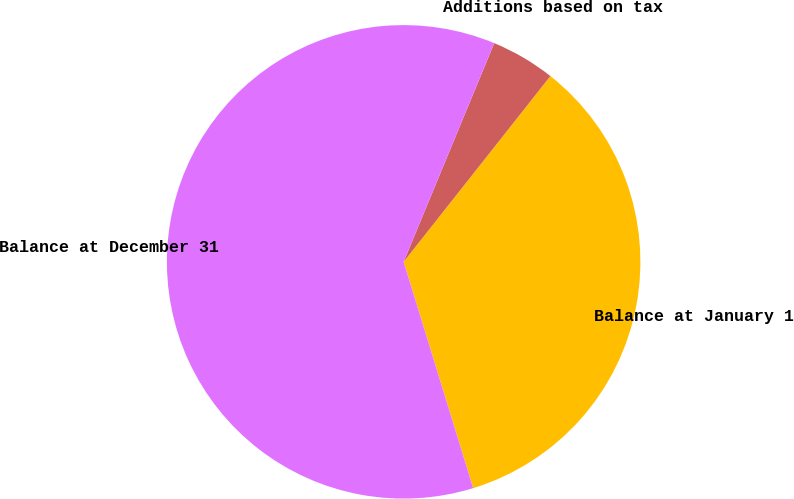Convert chart. <chart><loc_0><loc_0><loc_500><loc_500><pie_chart><fcel>Balance at January 1<fcel>Additions based on tax<fcel>Balance at December 31<nl><fcel>34.61%<fcel>4.39%<fcel>60.99%<nl></chart> 